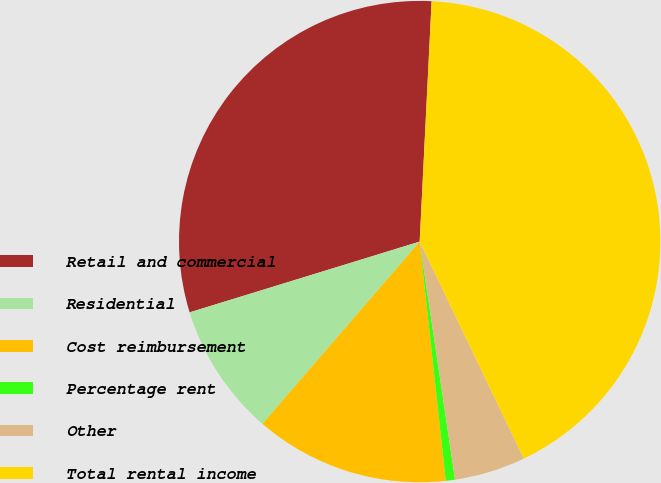<chart> <loc_0><loc_0><loc_500><loc_500><pie_chart><fcel>Retail and commercial<fcel>Residential<fcel>Cost reimbursement<fcel>Percentage rent<fcel>Other<fcel>Total rental income<nl><fcel>30.54%<fcel>8.92%<fcel>13.06%<fcel>0.62%<fcel>4.77%<fcel>42.09%<nl></chart> 